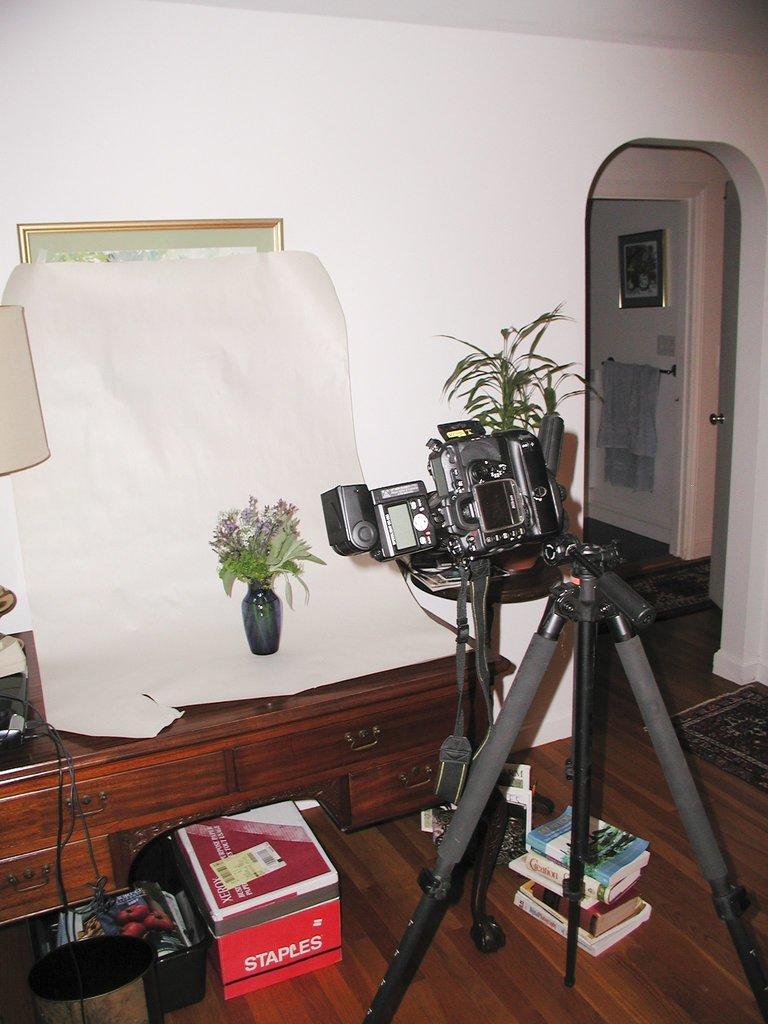Describe this image in one or two sentences. This picture shows camera with a stand and we see a plant and flower pot and we see few books and a box on the floor and we see a photo frame on the wall and a towel. 